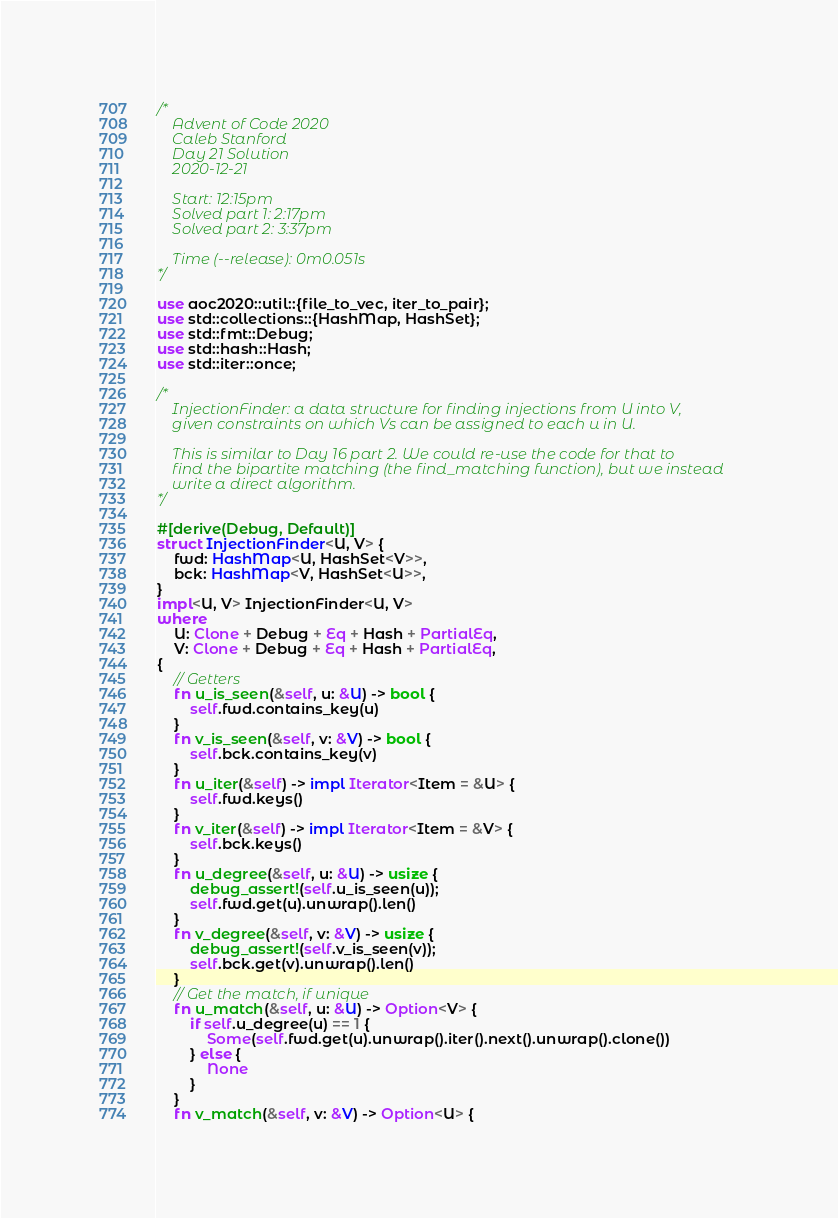<code> <loc_0><loc_0><loc_500><loc_500><_Rust_>/*
    Advent of Code 2020
    Caleb Stanford
    Day 21 Solution
    2020-12-21

    Start: 12:15pm
    Solved part 1: 2:17pm
    Solved part 2: 3:37pm

    Time (--release): 0m0.051s
*/

use aoc2020::util::{file_to_vec, iter_to_pair};
use std::collections::{HashMap, HashSet};
use std::fmt::Debug;
use std::hash::Hash;
use std::iter::once;

/*
    InjectionFinder: a data structure for finding injections from U into V,
    given constraints on which Vs can be assigned to each u in U.

    This is similar to Day 16 part 2. We could re-use the code for that to
    find the bipartite matching (the find_matching function), but we instead
    write a direct algorithm.
*/

#[derive(Debug, Default)]
struct InjectionFinder<U, V> {
    fwd: HashMap<U, HashSet<V>>,
    bck: HashMap<V, HashSet<U>>,
}
impl<U, V> InjectionFinder<U, V>
where
    U: Clone + Debug + Eq + Hash + PartialEq,
    V: Clone + Debug + Eq + Hash + PartialEq,
{
    // Getters
    fn u_is_seen(&self, u: &U) -> bool {
        self.fwd.contains_key(u)
    }
    fn v_is_seen(&self, v: &V) -> bool {
        self.bck.contains_key(v)
    }
    fn u_iter(&self) -> impl Iterator<Item = &U> {
        self.fwd.keys()
    }
    fn v_iter(&self) -> impl Iterator<Item = &V> {
        self.bck.keys()
    }
    fn u_degree(&self, u: &U) -> usize {
        debug_assert!(self.u_is_seen(u));
        self.fwd.get(u).unwrap().len()
    }
    fn v_degree(&self, v: &V) -> usize {
        debug_assert!(self.v_is_seen(v));
        self.bck.get(v).unwrap().len()
    }
    // Get the match, if unique
    fn u_match(&self, u: &U) -> Option<V> {
        if self.u_degree(u) == 1 {
            Some(self.fwd.get(u).unwrap().iter().next().unwrap().clone())
        } else {
            None
        }
    }
    fn v_match(&self, v: &V) -> Option<U> {</code> 